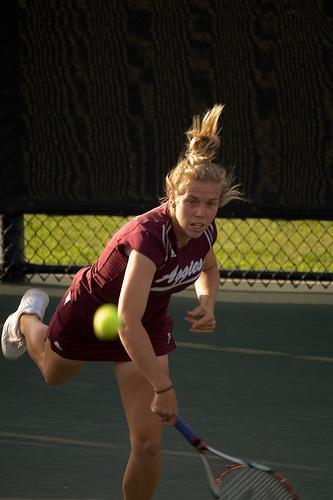How many legs are the woman standing on?
Give a very brief answer. 1. How many tennis players are in the photo?
Give a very brief answer. 1. 